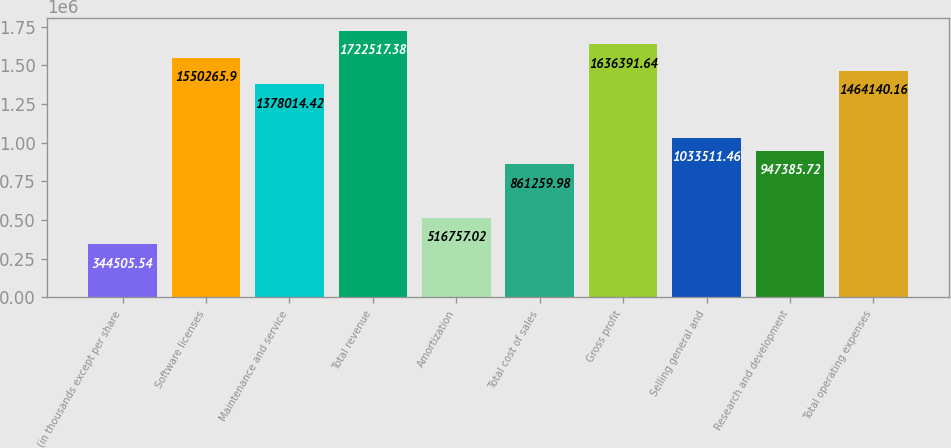<chart> <loc_0><loc_0><loc_500><loc_500><bar_chart><fcel>(in thousands except per share<fcel>Software licenses<fcel>Maintenance and service<fcel>Total revenue<fcel>Amortization<fcel>Total cost of sales<fcel>Gross profit<fcel>Selling general and<fcel>Research and development<fcel>Total operating expenses<nl><fcel>344506<fcel>1.55027e+06<fcel>1.37801e+06<fcel>1.72252e+06<fcel>516757<fcel>861260<fcel>1.63639e+06<fcel>1.03351e+06<fcel>947386<fcel>1.46414e+06<nl></chart> 